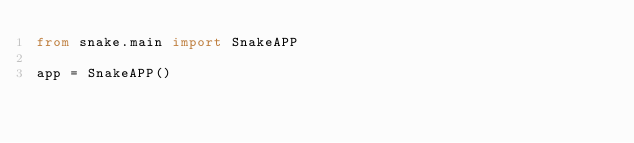Convert code to text. <code><loc_0><loc_0><loc_500><loc_500><_Python_>from snake.main import SnakeAPP

app = SnakeAPP()
</code> 